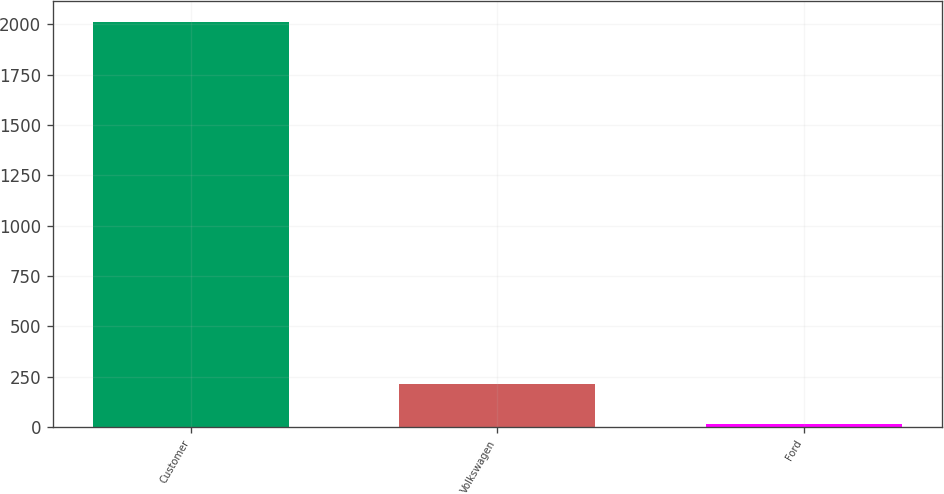Convert chart. <chart><loc_0><loc_0><loc_500><loc_500><bar_chart><fcel>Customer<fcel>Volkswagen<fcel>Ford<nl><fcel>2013<fcel>213.9<fcel>14<nl></chart> 